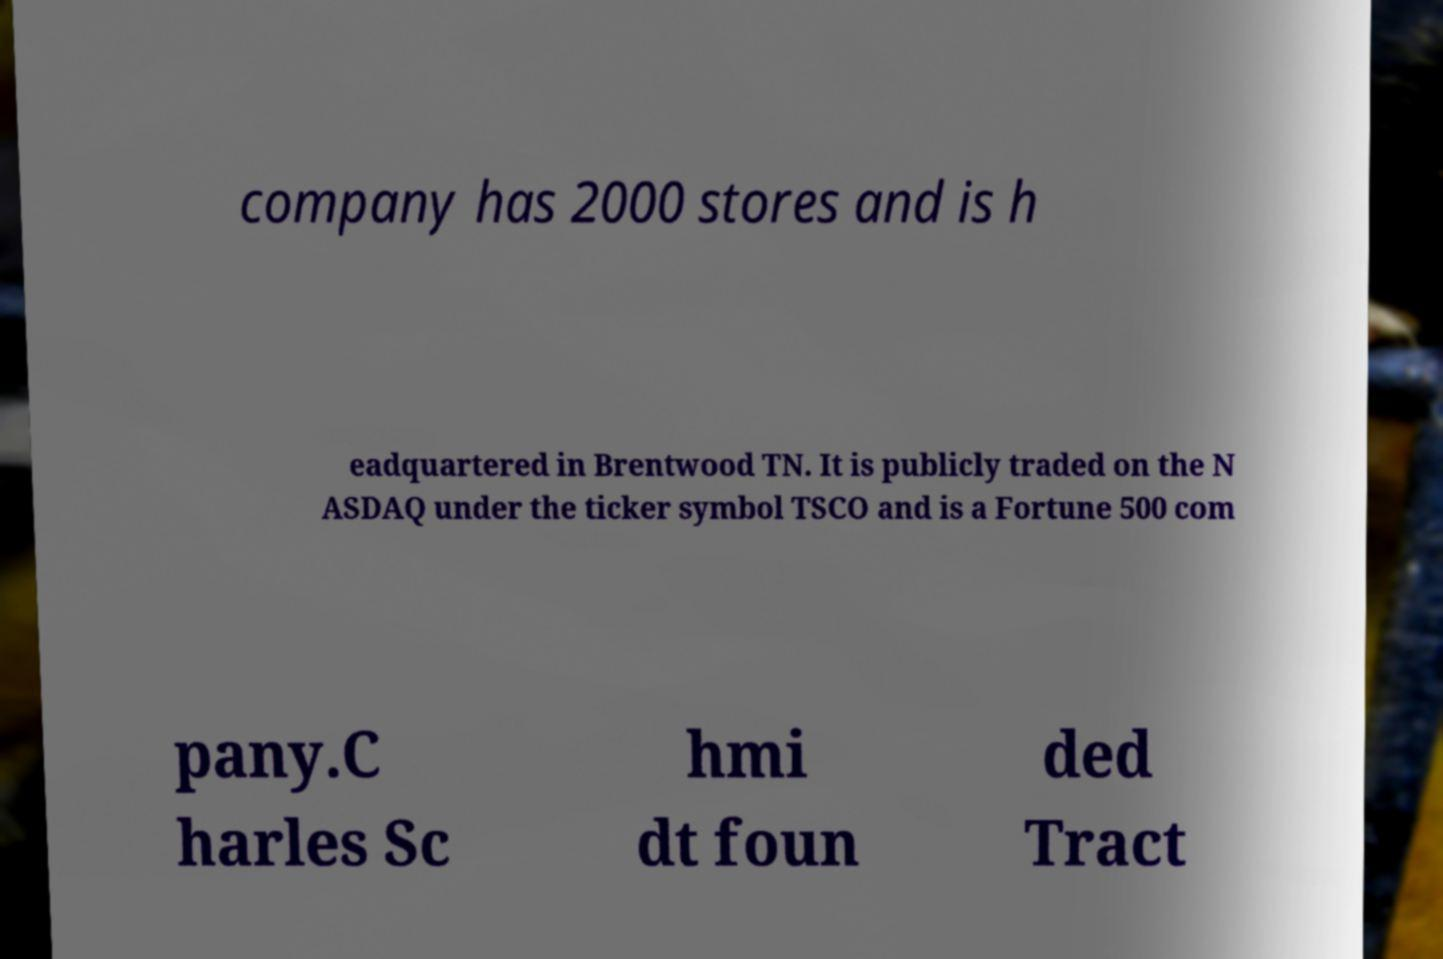There's text embedded in this image that I need extracted. Can you transcribe it verbatim? company has 2000 stores and is h eadquartered in Brentwood TN. It is publicly traded on the N ASDAQ under the ticker symbol TSCO and is a Fortune 500 com pany.C harles Sc hmi dt foun ded Tract 